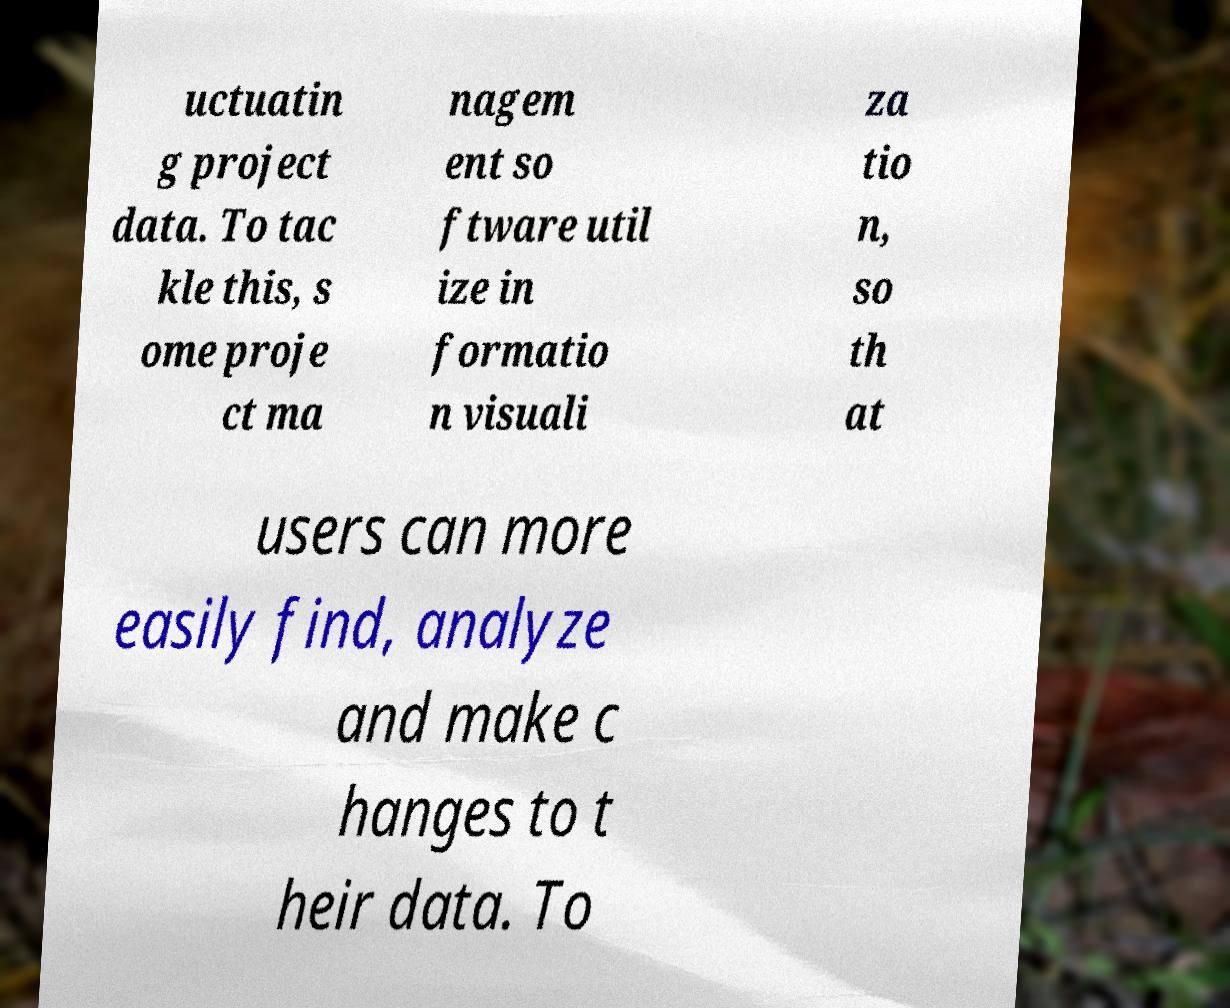I need the written content from this picture converted into text. Can you do that? uctuatin g project data. To tac kle this, s ome proje ct ma nagem ent so ftware util ize in formatio n visuali za tio n, so th at users can more easily find, analyze and make c hanges to t heir data. To 